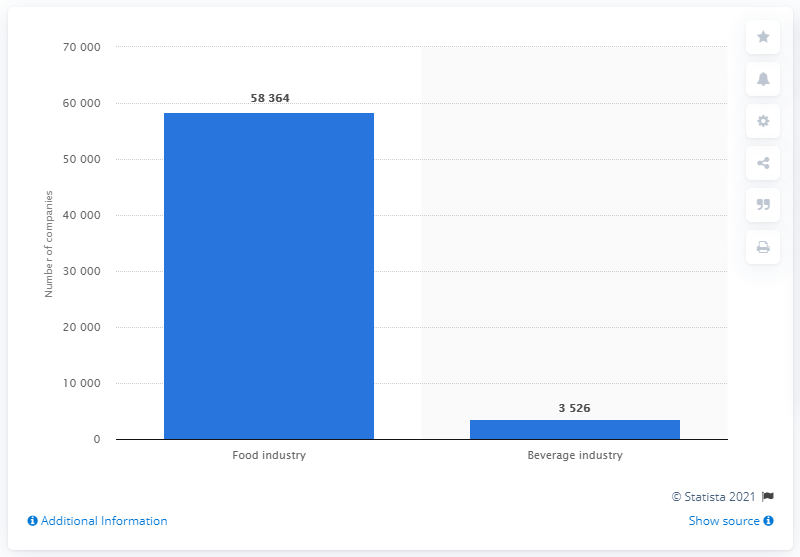Can you explain why there might be such a large difference between the number of companies in the food industry versus the beverage industry? The significant difference in the number of companies can be attributed to various factors. The food industry often encompasses a wider range of products and services, including perishables, packaged goods, and food processing, which may require more companies to meet diverse consumer needs. In contrast, the beverage industry might be more consolidated with fewer, but larger companies, focusing on beverages like wines, spirits, and soft drinks. 